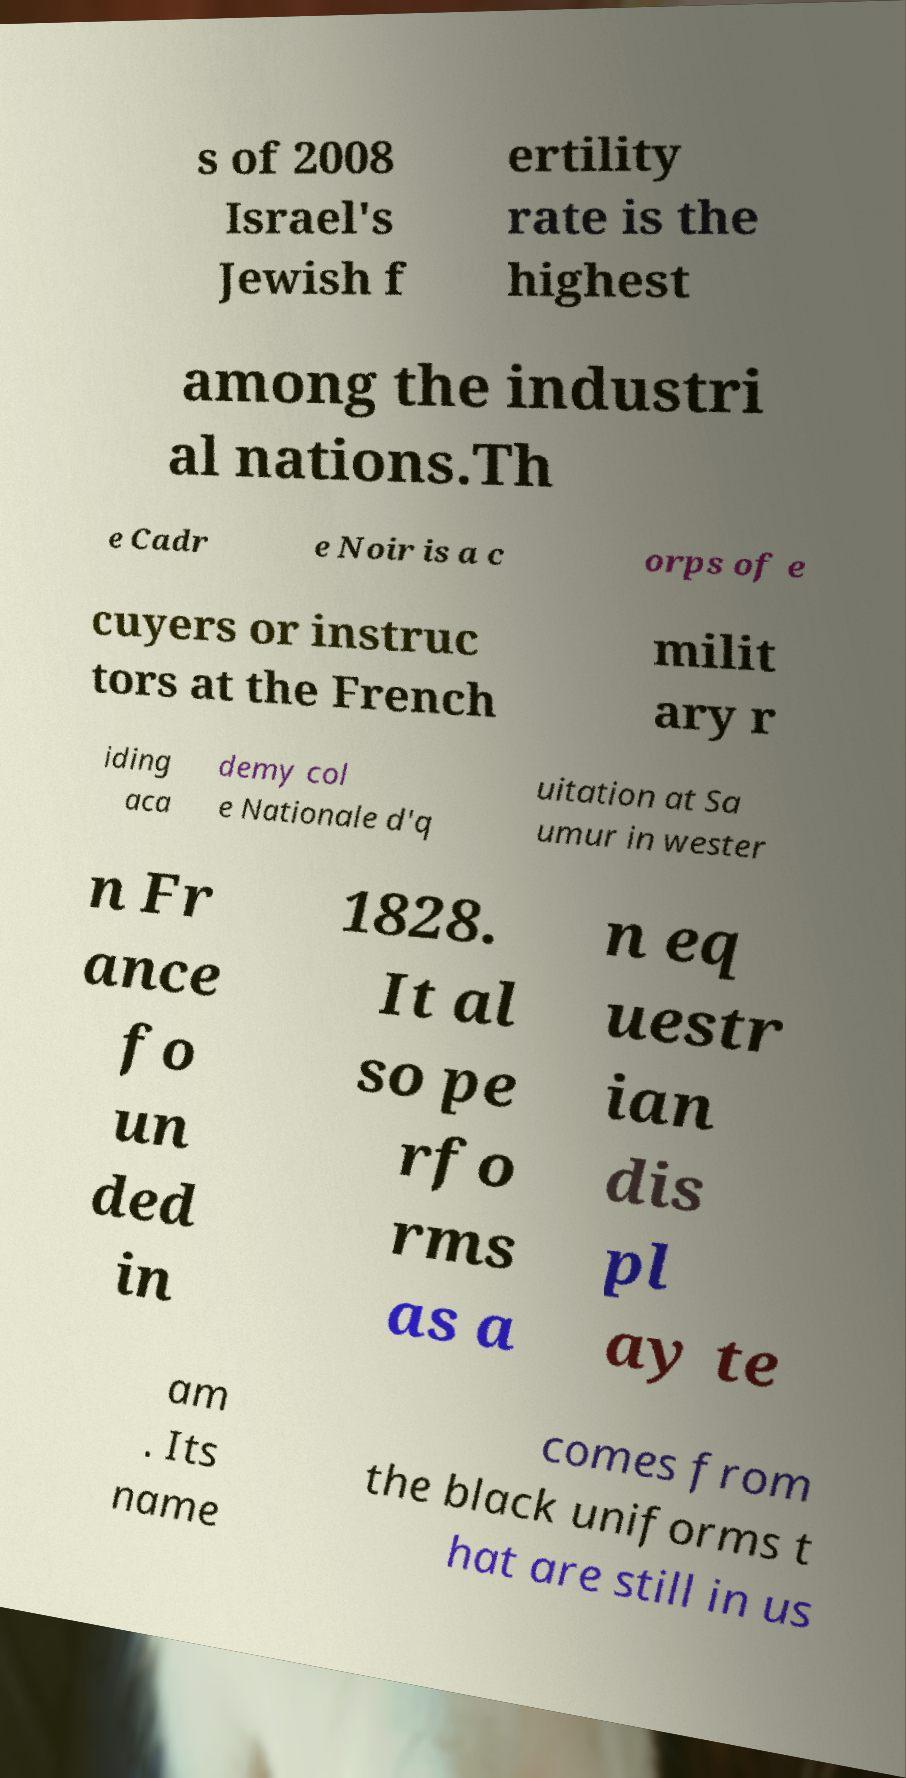There's text embedded in this image that I need extracted. Can you transcribe it verbatim? s of 2008 Israel's Jewish f ertility rate is the highest among the industri al nations.Th e Cadr e Noir is a c orps of e cuyers or instruc tors at the French milit ary r iding aca demy col e Nationale d'q uitation at Sa umur in wester n Fr ance fo un ded in 1828. It al so pe rfo rms as a n eq uestr ian dis pl ay te am . Its name comes from the black uniforms t hat are still in us 